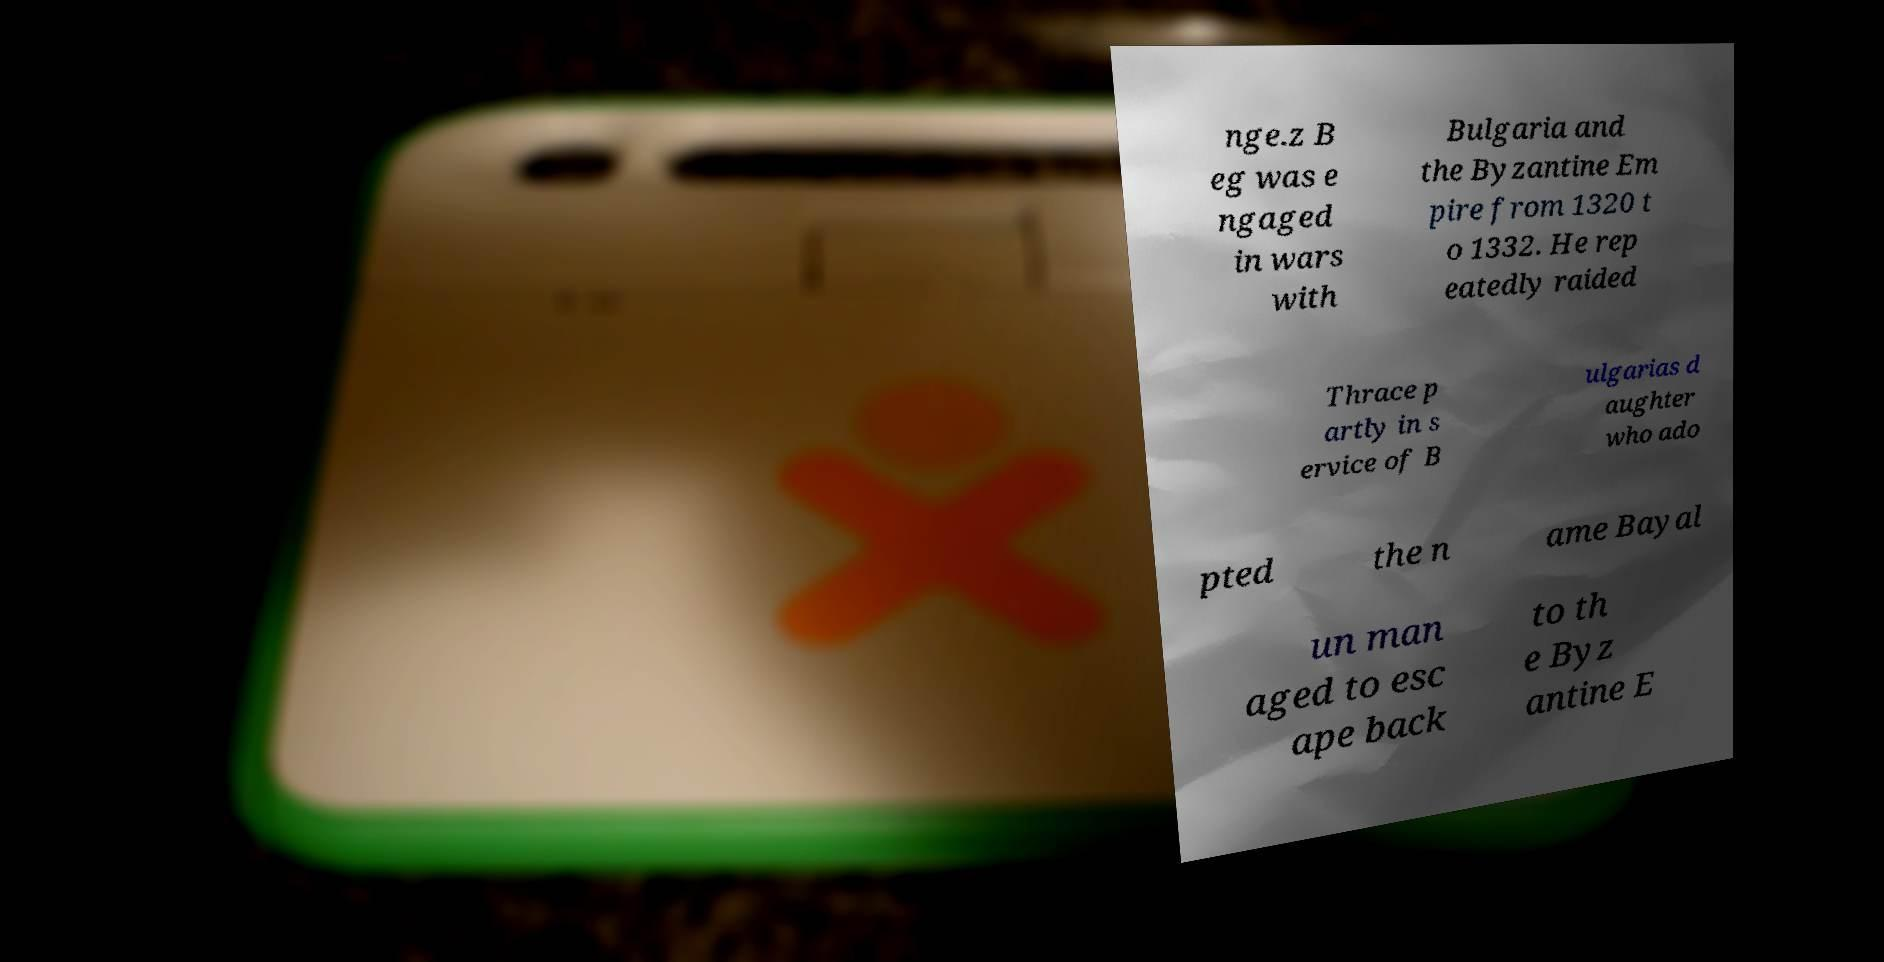For documentation purposes, I need the text within this image transcribed. Could you provide that? nge.z B eg was e ngaged in wars with Bulgaria and the Byzantine Em pire from 1320 t o 1332. He rep eatedly raided Thrace p artly in s ervice of B ulgarias d aughter who ado pted the n ame Bayal un man aged to esc ape back to th e Byz antine E 